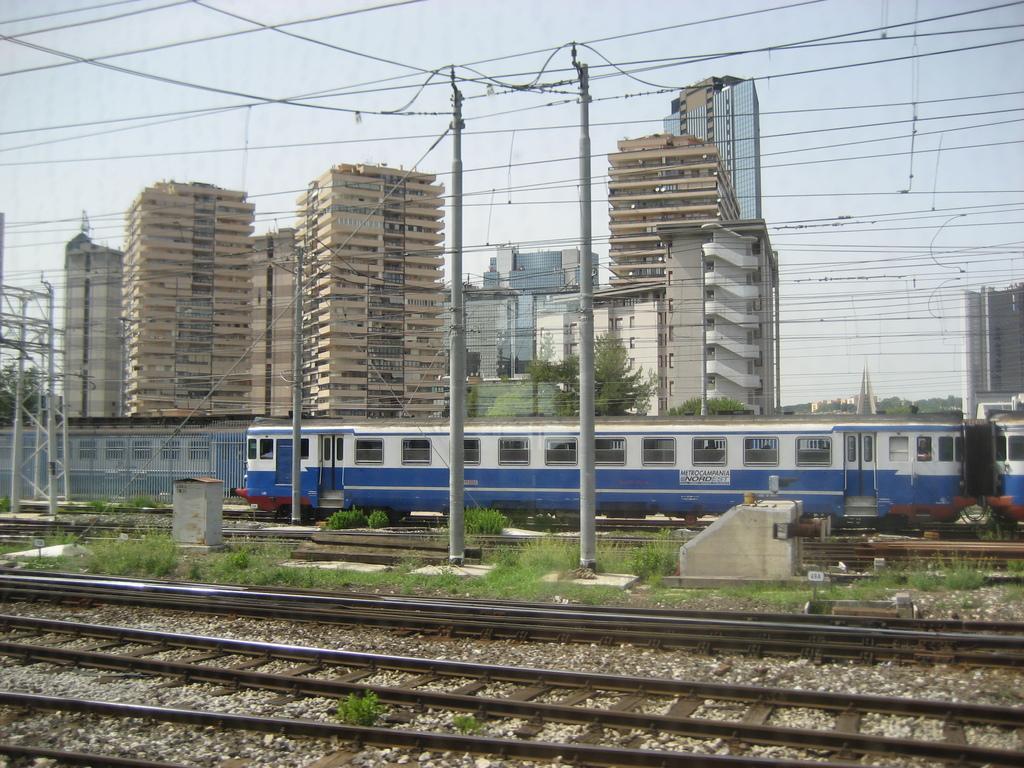Describe this image in one or two sentences. In this picture we can see grass, railway tracks and stones at the bottom, we can see a train, poles, wires and fencing in the middle, in the background there are some buildings and trees, we can see the sky at the top of the picture. 